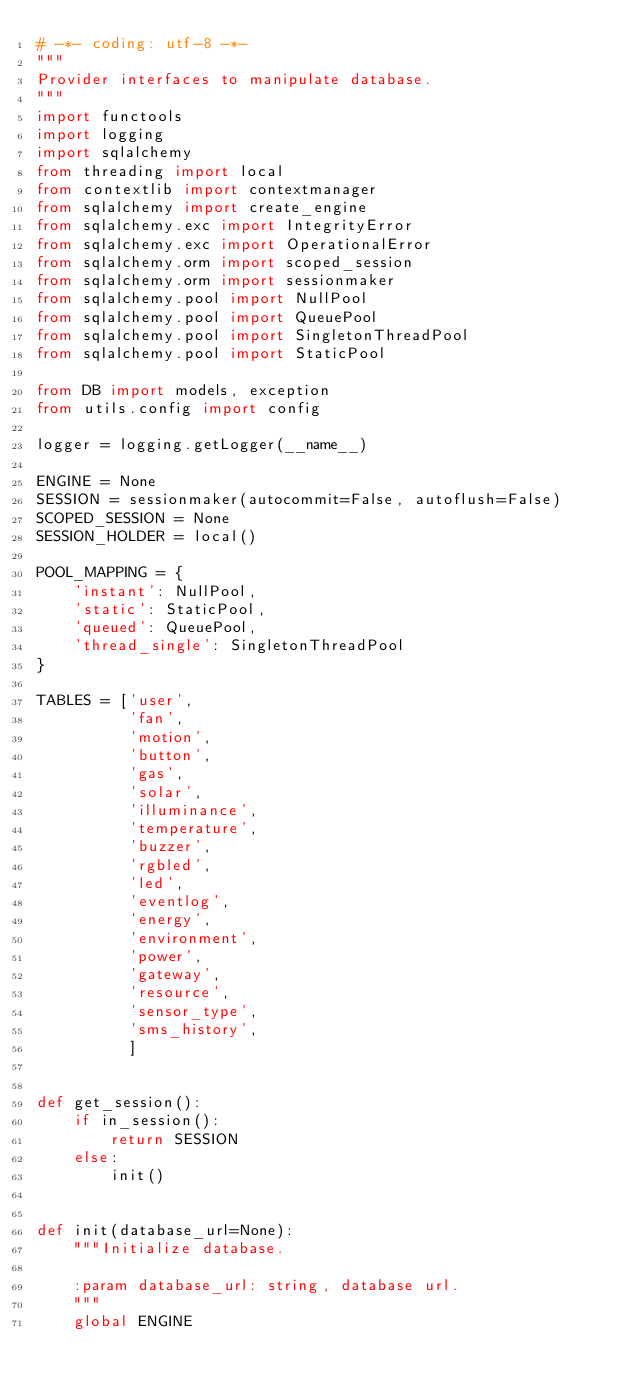Convert code to text. <code><loc_0><loc_0><loc_500><loc_500><_Python_># -*- coding: utf-8 -*-
"""
Provider interfaces to manipulate database.
"""
import functools
import logging
import sqlalchemy
from threading import local
from contextlib import contextmanager
from sqlalchemy import create_engine
from sqlalchemy.exc import IntegrityError
from sqlalchemy.exc import OperationalError
from sqlalchemy.orm import scoped_session
from sqlalchemy.orm import sessionmaker
from sqlalchemy.pool import NullPool
from sqlalchemy.pool import QueuePool
from sqlalchemy.pool import SingletonThreadPool
from sqlalchemy.pool import StaticPool

from DB import models, exception
from utils.config import config

logger = logging.getLogger(__name__)

ENGINE = None
SESSION = sessionmaker(autocommit=False, autoflush=False)
SCOPED_SESSION = None
SESSION_HOLDER = local()

POOL_MAPPING = {
    'instant': NullPool,
    'static': StaticPool,
    'queued': QueuePool,
    'thread_single': SingletonThreadPool
}

TABLES = ['user',
          'fan',
          'motion',
          'button',
          'gas',
          'solar',
          'illuminance',
          'temperature',
          'buzzer',
          'rgbled',
          'led',
          'eventlog',
          'energy',
          'environment',
          'power',
          'gateway',
          'resource',
          'sensor_type',
          'sms_history',
          ]


def get_session():
    if in_session():
        return SESSION
    else:
        init()


def init(database_url=None):
    """Initialize database.

    :param database_url: string, database url.
    """
    global ENGINE</code> 